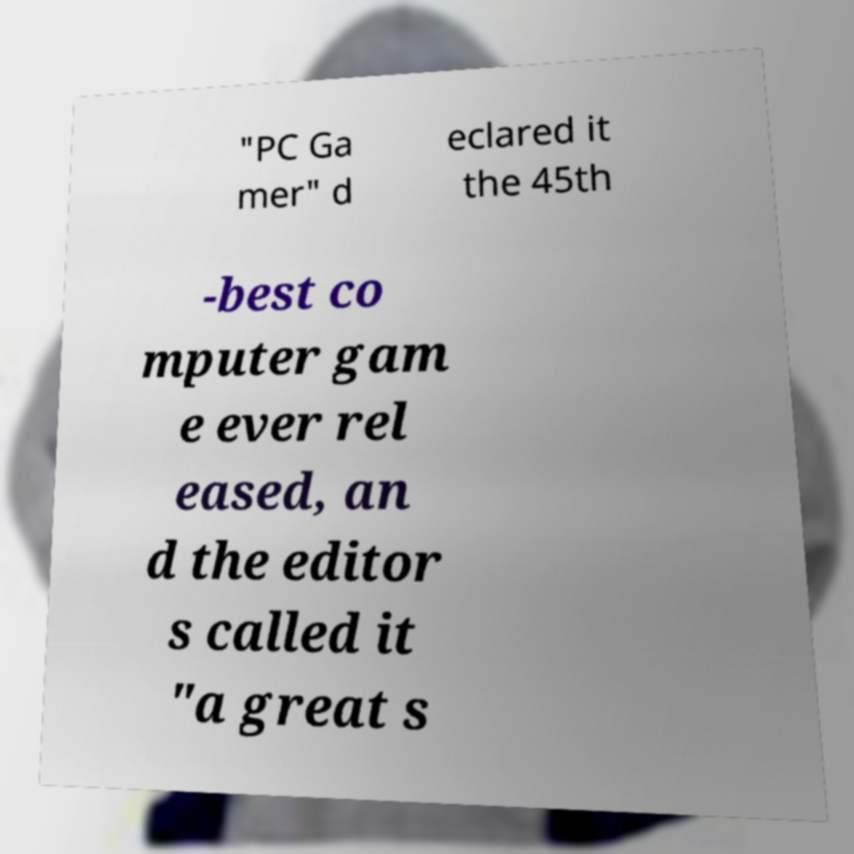There's text embedded in this image that I need extracted. Can you transcribe it verbatim? "PC Ga mer" d eclared it the 45th -best co mputer gam e ever rel eased, an d the editor s called it "a great s 